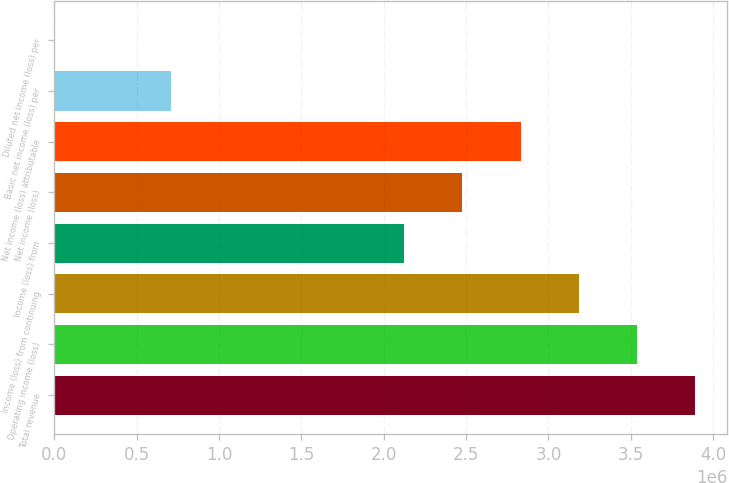Convert chart to OTSL. <chart><loc_0><loc_0><loc_500><loc_500><bar_chart><fcel>Total revenue<fcel>Operating income (loss)<fcel>Income (loss) from continuing<fcel>Income (loss) from<fcel>Net income (loss)<fcel>Net income (loss) attributable<fcel>Basic net income (loss) per<fcel>Diluted net income (loss) per<nl><fcel>3.89239e+06<fcel>3.53854e+06<fcel>3.18469e+06<fcel>2.12312e+06<fcel>2.47698e+06<fcel>2.83083e+06<fcel>707708<fcel>0.01<nl></chart> 